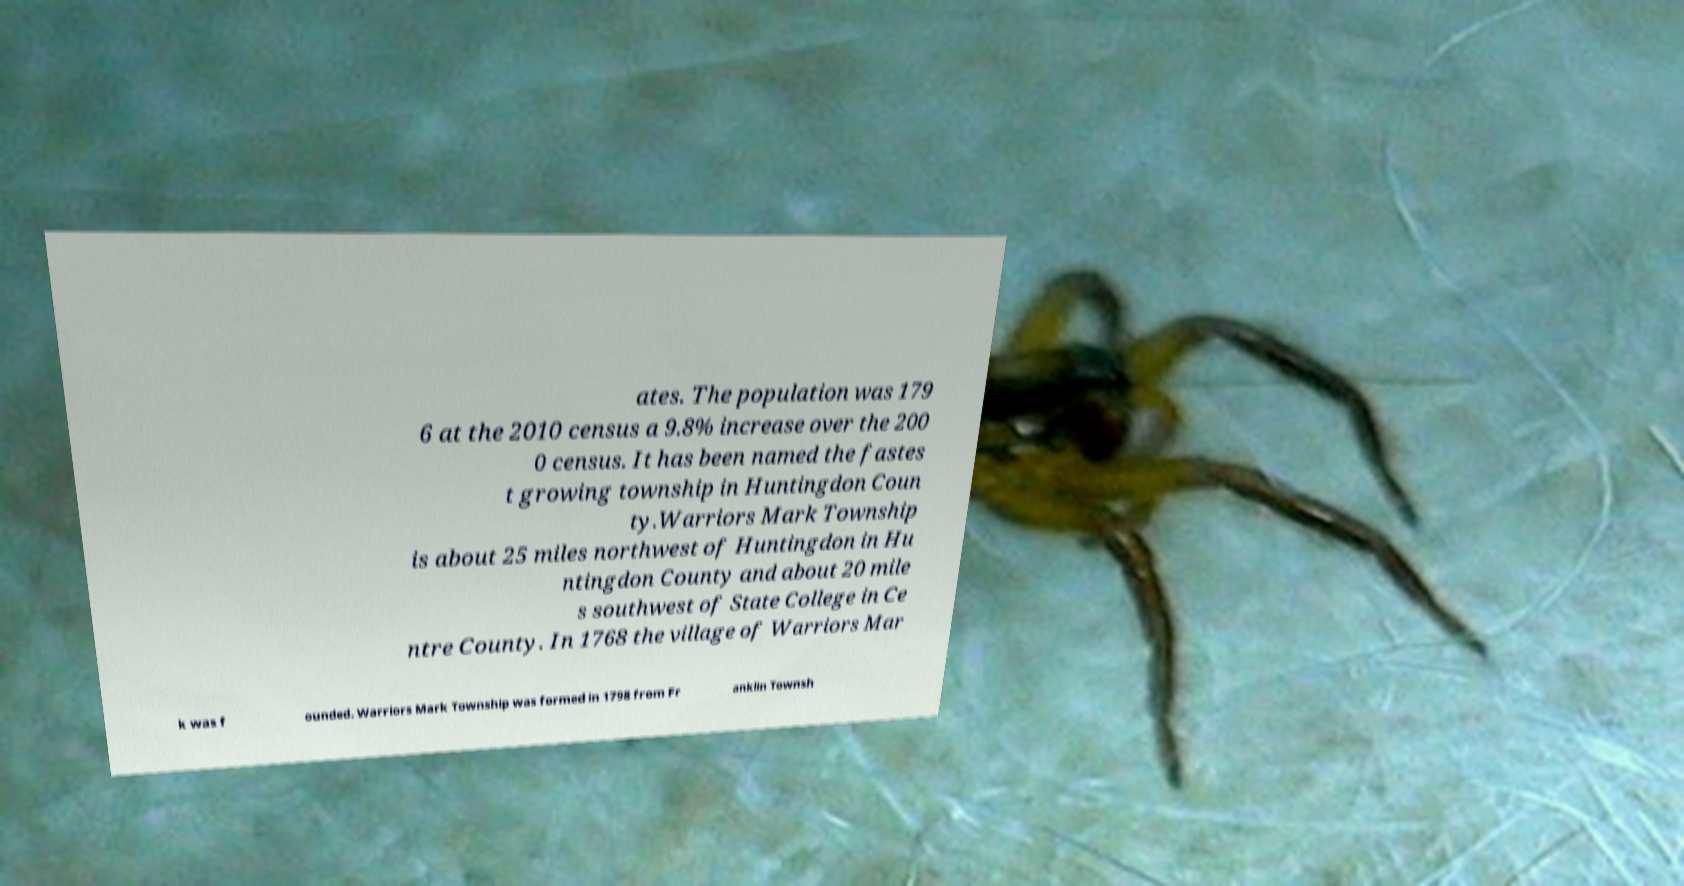Could you extract and type out the text from this image? ates. The population was 179 6 at the 2010 census a 9.8% increase over the 200 0 census. It has been named the fastes t growing township in Huntingdon Coun ty.Warriors Mark Township is about 25 miles northwest of Huntingdon in Hu ntingdon County and about 20 mile s southwest of State College in Ce ntre County. In 1768 the village of Warriors Mar k was f ounded. Warriors Mark Township was formed in 1798 from Fr anklin Townsh 